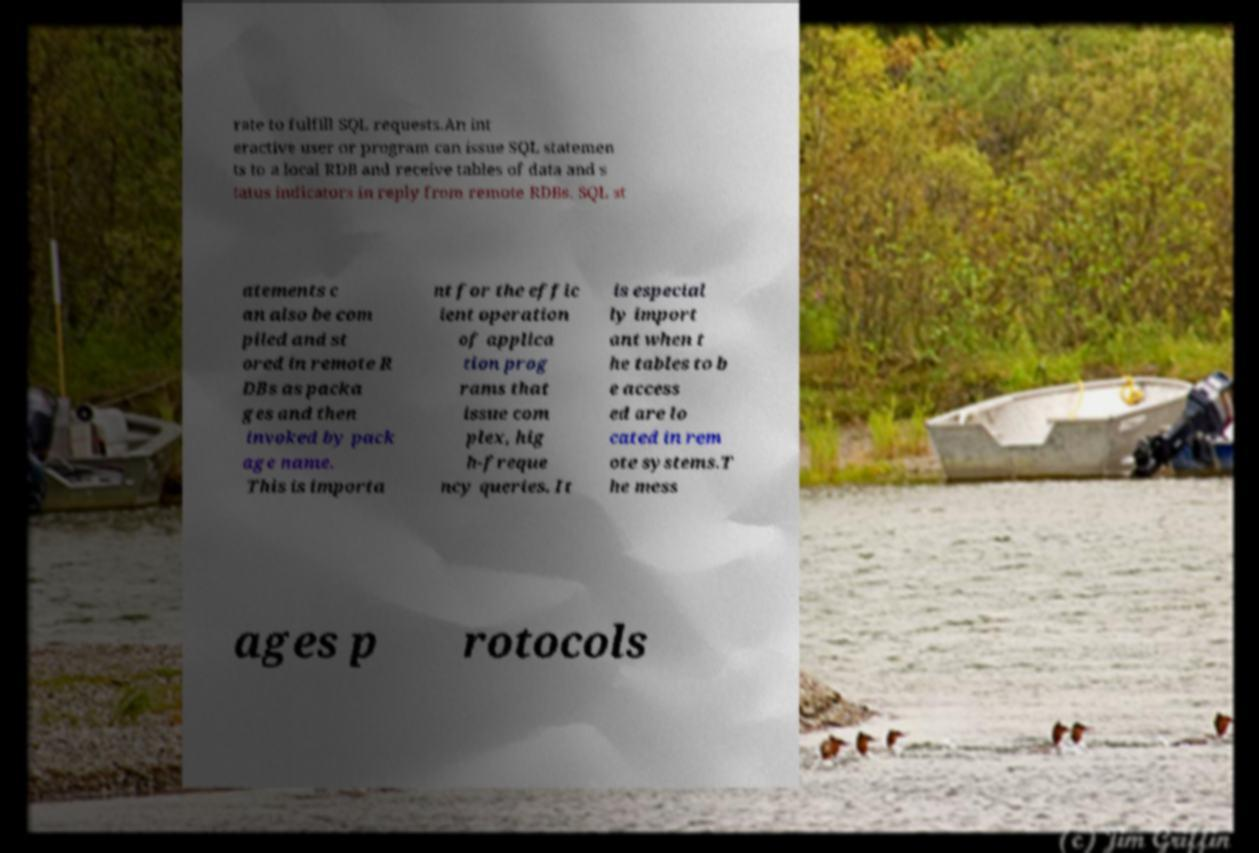Can you accurately transcribe the text from the provided image for me? rate to fulfill SQL requests.An int eractive user or program can issue SQL statemen ts to a local RDB and receive tables of data and s tatus indicators in reply from remote RDBs. SQL st atements c an also be com piled and st ored in remote R DBs as packa ges and then invoked by pack age name. This is importa nt for the effic ient operation of applica tion prog rams that issue com plex, hig h-freque ncy queries. It is especial ly import ant when t he tables to b e access ed are lo cated in rem ote systems.T he mess ages p rotocols 